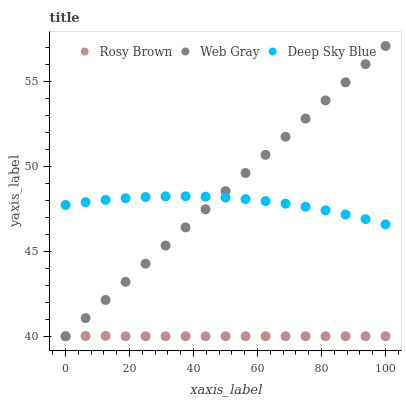Does Rosy Brown have the minimum area under the curve?
Answer yes or no. Yes. Does Web Gray have the maximum area under the curve?
Answer yes or no. Yes. Does Deep Sky Blue have the minimum area under the curve?
Answer yes or no. No. Does Deep Sky Blue have the maximum area under the curve?
Answer yes or no. No. Is Web Gray the smoothest?
Answer yes or no. Yes. Is Deep Sky Blue the roughest?
Answer yes or no. Yes. Is Deep Sky Blue the smoothest?
Answer yes or no. No. Is Web Gray the roughest?
Answer yes or no. No. Does Rosy Brown have the lowest value?
Answer yes or no. Yes. Does Deep Sky Blue have the lowest value?
Answer yes or no. No. Does Web Gray have the highest value?
Answer yes or no. Yes. Does Deep Sky Blue have the highest value?
Answer yes or no. No. Is Rosy Brown less than Deep Sky Blue?
Answer yes or no. Yes. Is Deep Sky Blue greater than Rosy Brown?
Answer yes or no. Yes. Does Deep Sky Blue intersect Web Gray?
Answer yes or no. Yes. Is Deep Sky Blue less than Web Gray?
Answer yes or no. No. Is Deep Sky Blue greater than Web Gray?
Answer yes or no. No. Does Rosy Brown intersect Deep Sky Blue?
Answer yes or no. No. 